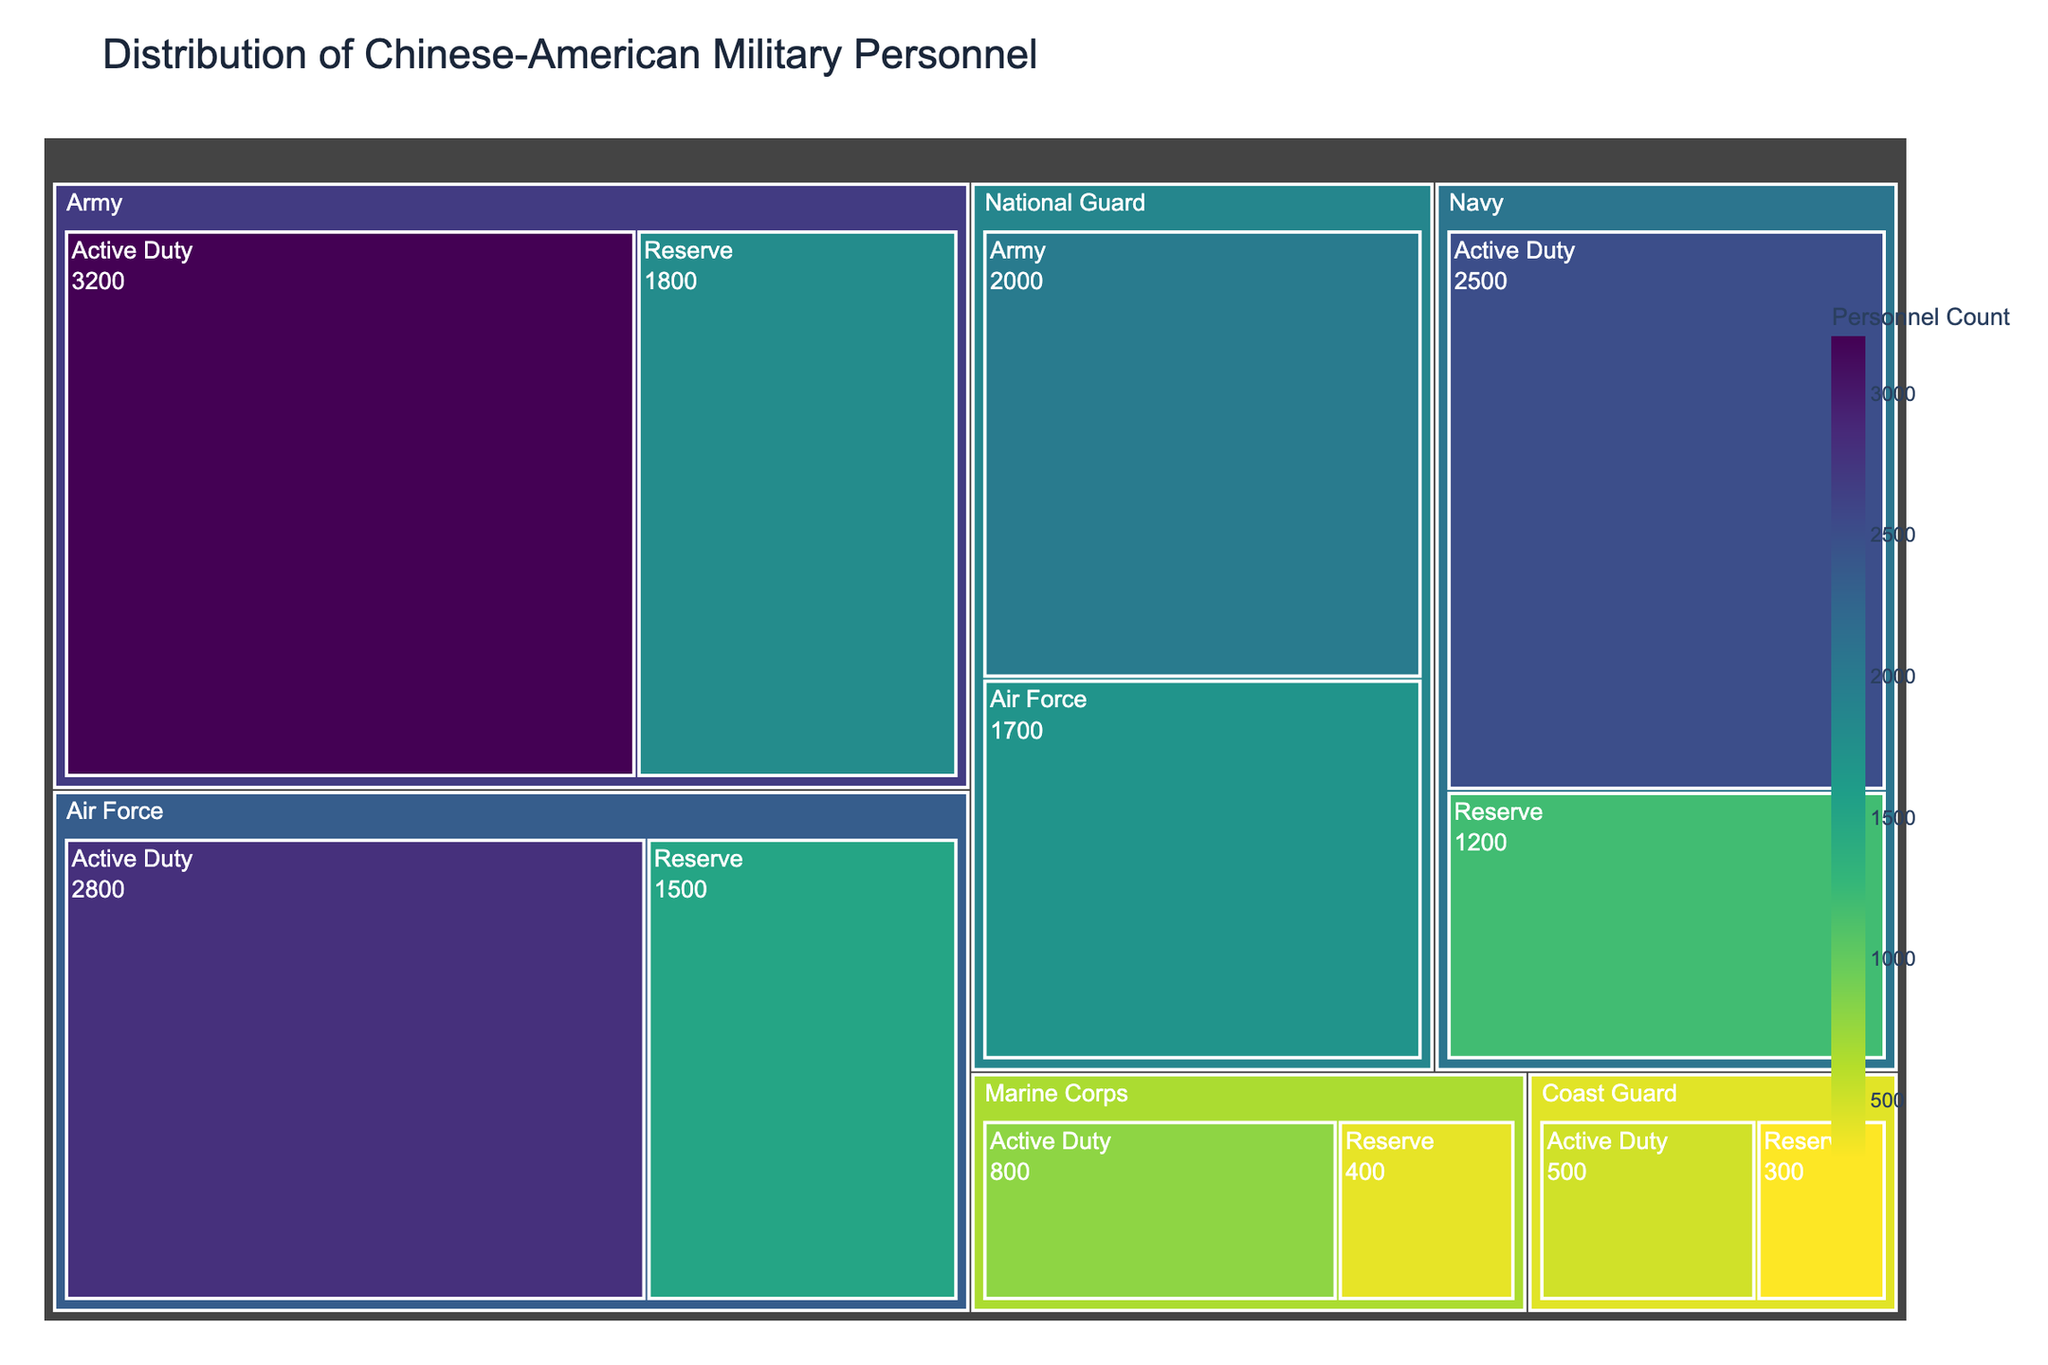How many personnel are there in the Active Duty Army? To determine the number of personnel in the Active Duty Army, look at the treemap segment for the Army branch and then find the Active Duty section.
Answer: 3200 What's the total number of personnel in the National Guard? To get the total number of personnel in the National Guard, sum the personnel of both the Army and Air Force sections within the National Guard. The Army segment has 2000 personnel, and the Air Force has 1700 personnel. 2000 + 1700 = 3700
Answer: 3700 Which branch has the least number of Active Duty personnel? Examine all branches' Active Duty segments and compare the values. The Coast Guard's Active Duty section has the lowest number with 500 personnel.
Answer: Coast Guard How many more Active Duty personnel are there in the Navy compared to the Marine Corps? Find the difference in the number of Active Duty personnel between the Navy and the Marine Corps. The Navy has 2500 and the Marine Corps has 800 personnel. 2500 - 800 = 1700
Answer: 1700 Identify the branch with the highest total personnel. To find the branch with the highest total personnel, sum the personnel counts for Active Duty and Reserve for each branch. Compare these sums to identify the highest. The Army has 3200 (Active Duty) + 1800 (Reserve) + 2000 (National Guard) = 7000 personnel.
Answer: Army What is the approximate ratio of Reserve to Active Duty personnel in the Air Force? Calculate the ratio by dividing the number of Reserve personnel by Active Duty personnel in the Air Force. Reserve personnel count is 1500, and Active Duty count is 2800. 1500 / 2800 ≈ 0.54
Answer: 0.54 How does the number of personnel in the Active Duty Army compare to those in the Reserve Army? Compare the personnel counts directly. The Active Duty Army has 3200 personnel, whereas the Reserve Army has 1800. 3200 is greater than 1800.
Answer: Active Duty Army has more Which has more personnel, Reserve Navy or Reserve Marine Corps? Compare the personnel counts of the Reserve Navy and Reserve Marine Corps. Reserve Navy has 1200, and Reserve Marine Corps has 400. The Reserve Navy has more.
Answer: Reserve Navy Calculate the percentage of Active Duty personnel in the Air Force relative to the total number of personnel in the Air Force branch (including Reserve). First, calculate the total personnel in the Air Force by summing Active Duty (2800) and Reserve (1500), which is 4300. Then calculate the percentage of Active Duty personnel: (2800 / 4300) * 100 ≈ 65.12%
Answer: 65.12% How many branches have both Active Duty and Reserve personnel sections shown in the treemap? Count the branches that have both Active Duty and Reserve sections. The branches meeting this criterion are the Army, Navy, Air Force, Marine Corps, and Coast Guard.
Answer: 5 